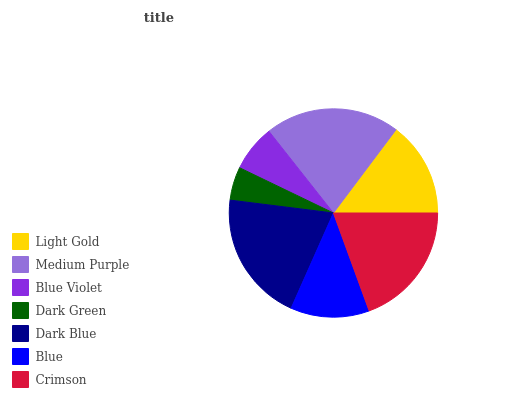Is Dark Green the minimum?
Answer yes or no. Yes. Is Medium Purple the maximum?
Answer yes or no. Yes. Is Blue Violet the minimum?
Answer yes or no. No. Is Blue Violet the maximum?
Answer yes or no. No. Is Medium Purple greater than Blue Violet?
Answer yes or no. Yes. Is Blue Violet less than Medium Purple?
Answer yes or no. Yes. Is Blue Violet greater than Medium Purple?
Answer yes or no. No. Is Medium Purple less than Blue Violet?
Answer yes or no. No. Is Light Gold the high median?
Answer yes or no. Yes. Is Light Gold the low median?
Answer yes or no. Yes. Is Blue Violet the high median?
Answer yes or no. No. Is Medium Purple the low median?
Answer yes or no. No. 